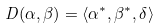<formula> <loc_0><loc_0><loc_500><loc_500>D ( \alpha , \beta ) = \langle \alpha ^ { * } , \beta ^ { * } , \delta \rangle</formula> 